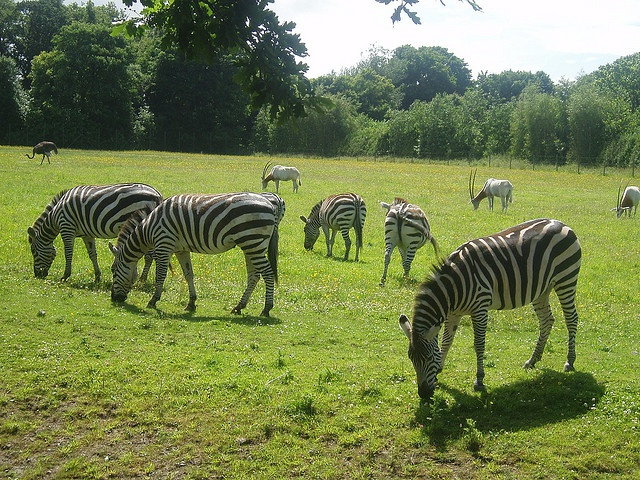Describe the objects in this image and their specific colors. I can see zebra in gray, black, darkgreen, and olive tones, zebra in gray, black, and darkgreen tones, zebra in gray, black, and darkgreen tones, zebra in gray, black, and darkgreen tones, and zebra in gray, black, darkgreen, and olive tones in this image. 